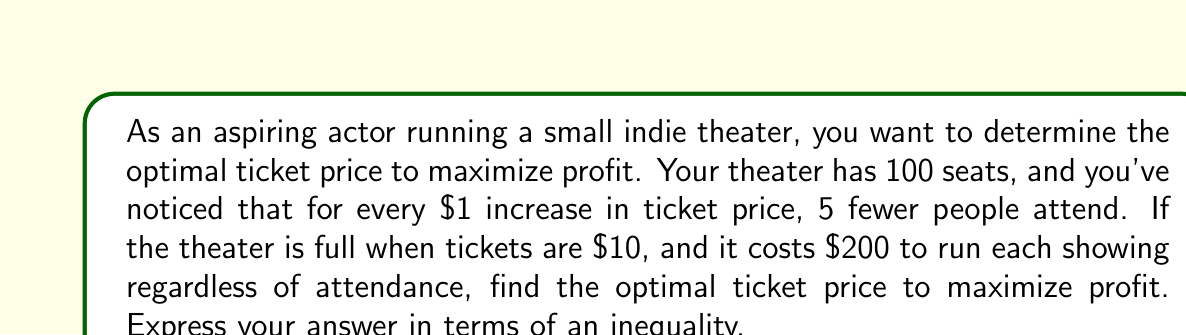Solve this math problem. Let's approach this step-by-step:

1) First, let's define our variables:
   $x$ = price increase from $10 (in dollars)
   $P$ = profit

2) We can express the number of attendees as a function of $x$:
   Attendees = $100 - 5x$

3) The revenue is the product of the ticket price and the number of attendees:
   Revenue = $(10 + x)(100 - 5x)$

4) Profit is revenue minus costs:
   $P = (10 + x)(100 - 5x) - 200$

5) Expand this equation:
   $P = 1000 + 100x - 50x - 5x^2 - 200$
   $P = 800 + 50x - 5x^2$

6) To find the maximum profit, we need to find where the derivative of $P$ with respect to $x$ equals zero:
   $\frac{dP}{dx} = 50 - 10x$
   $50 - 10x = 0$
   $x = 5$

7) To confirm this is a maximum, we can check the second derivative:
   $\frac{d^2P}{dx^2} = -10$ (negative, confirming a maximum)

8) Therefore, the optimal price increase is $5, making the optimal ticket price $15.

9) To express this as an inequality, we can state that the profit at the optimal price should be greater than or equal to the profit at any other price:

   $800 + 50(5) - 5(5)^2 \geq 800 + 50x - 5x^2$

   Simplifying:
   $925 \geq 800 + 50x - 5x^2$
   $125 \geq 50x - 5x^2$
   $5x^2 - 50x + 125 \geq 0$
Answer: $5x^2 - 50x + 125 \geq 0$, where $x$ is the price increase from $10. 